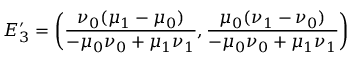<formula> <loc_0><loc_0><loc_500><loc_500>E _ { 3 } ^ { \prime } = \left ( \frac { \nu _ { 0 } ( \mu _ { 1 } - \mu _ { 0 } ) } { - \mu _ { 0 } \nu _ { 0 } + \mu _ { 1 } \nu _ { 1 } } , \frac { \mu _ { 0 } ( \nu _ { 1 } - \nu _ { 0 } ) } { - \mu _ { 0 } \nu _ { 0 } + \mu _ { 1 } \nu _ { 1 } } \right )</formula> 